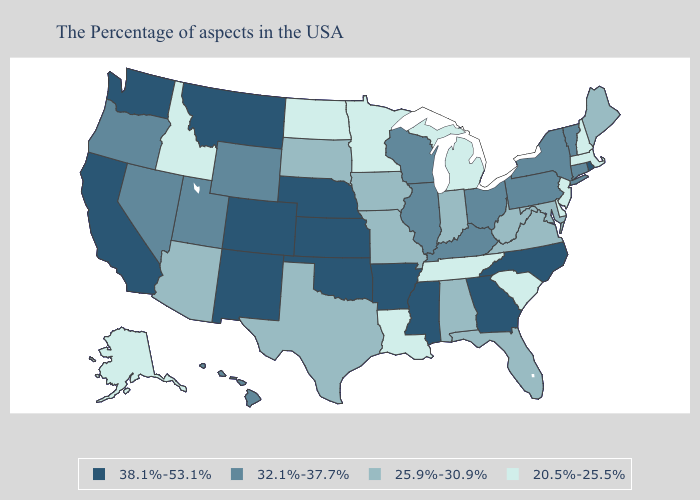Does Delaware have the highest value in the South?
Keep it brief. No. Does Michigan have the highest value in the USA?
Concise answer only. No. What is the lowest value in the USA?
Give a very brief answer. 20.5%-25.5%. Name the states that have a value in the range 32.1%-37.7%?
Give a very brief answer. Vermont, Connecticut, New York, Pennsylvania, Ohio, Kentucky, Wisconsin, Illinois, Wyoming, Utah, Nevada, Oregon, Hawaii. Does the first symbol in the legend represent the smallest category?
Short answer required. No. What is the value of Tennessee?
Write a very short answer. 20.5%-25.5%. Name the states that have a value in the range 38.1%-53.1%?
Keep it brief. Rhode Island, North Carolina, Georgia, Mississippi, Arkansas, Kansas, Nebraska, Oklahoma, Colorado, New Mexico, Montana, California, Washington. What is the lowest value in states that border Utah?
Answer briefly. 20.5%-25.5%. Name the states that have a value in the range 20.5%-25.5%?
Quick response, please. Massachusetts, New Hampshire, New Jersey, Delaware, South Carolina, Michigan, Tennessee, Louisiana, Minnesota, North Dakota, Idaho, Alaska. What is the value of Mississippi?
Keep it brief. 38.1%-53.1%. Name the states that have a value in the range 38.1%-53.1%?
Write a very short answer. Rhode Island, North Carolina, Georgia, Mississippi, Arkansas, Kansas, Nebraska, Oklahoma, Colorado, New Mexico, Montana, California, Washington. Among the states that border Florida , which have the lowest value?
Quick response, please. Alabama. Does New Hampshire have the highest value in the USA?
Quick response, please. No. Which states have the lowest value in the Northeast?
Be succinct. Massachusetts, New Hampshire, New Jersey. What is the value of New Mexico?
Write a very short answer. 38.1%-53.1%. 